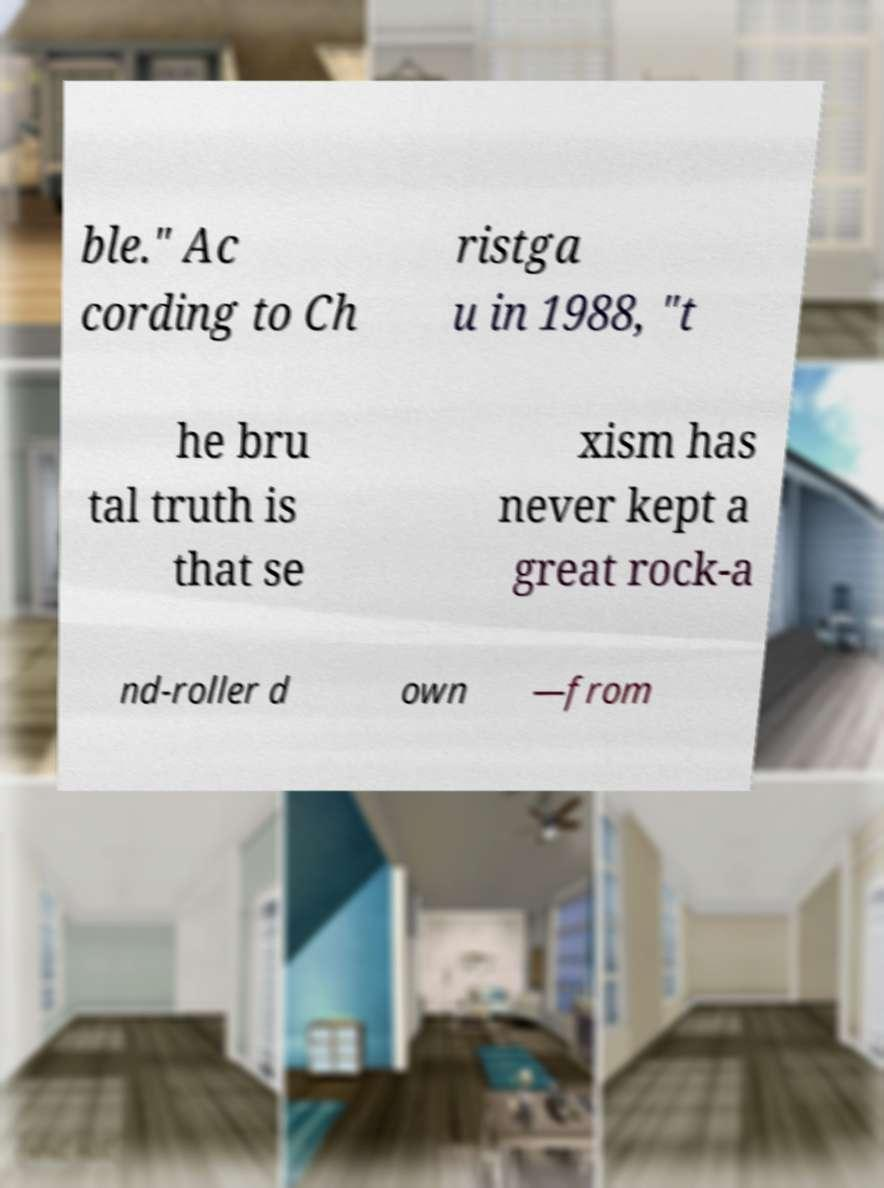Please read and relay the text visible in this image. What does it say? ble." Ac cording to Ch ristga u in 1988, "t he bru tal truth is that se xism has never kept a great rock-a nd-roller d own —from 